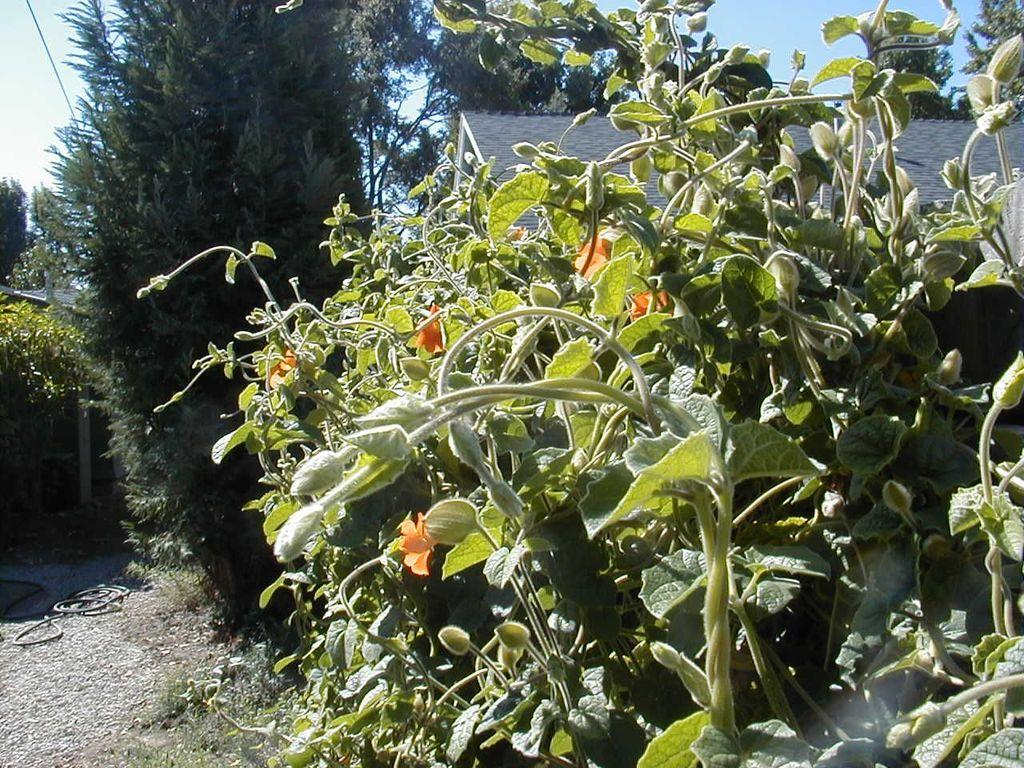What type of living organisms can be seen in the image? Plants can be seen in the image. What type of structure is visible in the image? There is a house in the image. What can be seen in the background of the image? Trees and the sky are visible in the background of the image. What type of terrain is visible in the bottom left of the image? Land is visible in the bottom left of the image. What thought is the kitten having while standing on the quicksand in the image? There is no kitten or quicksand present in the image. 